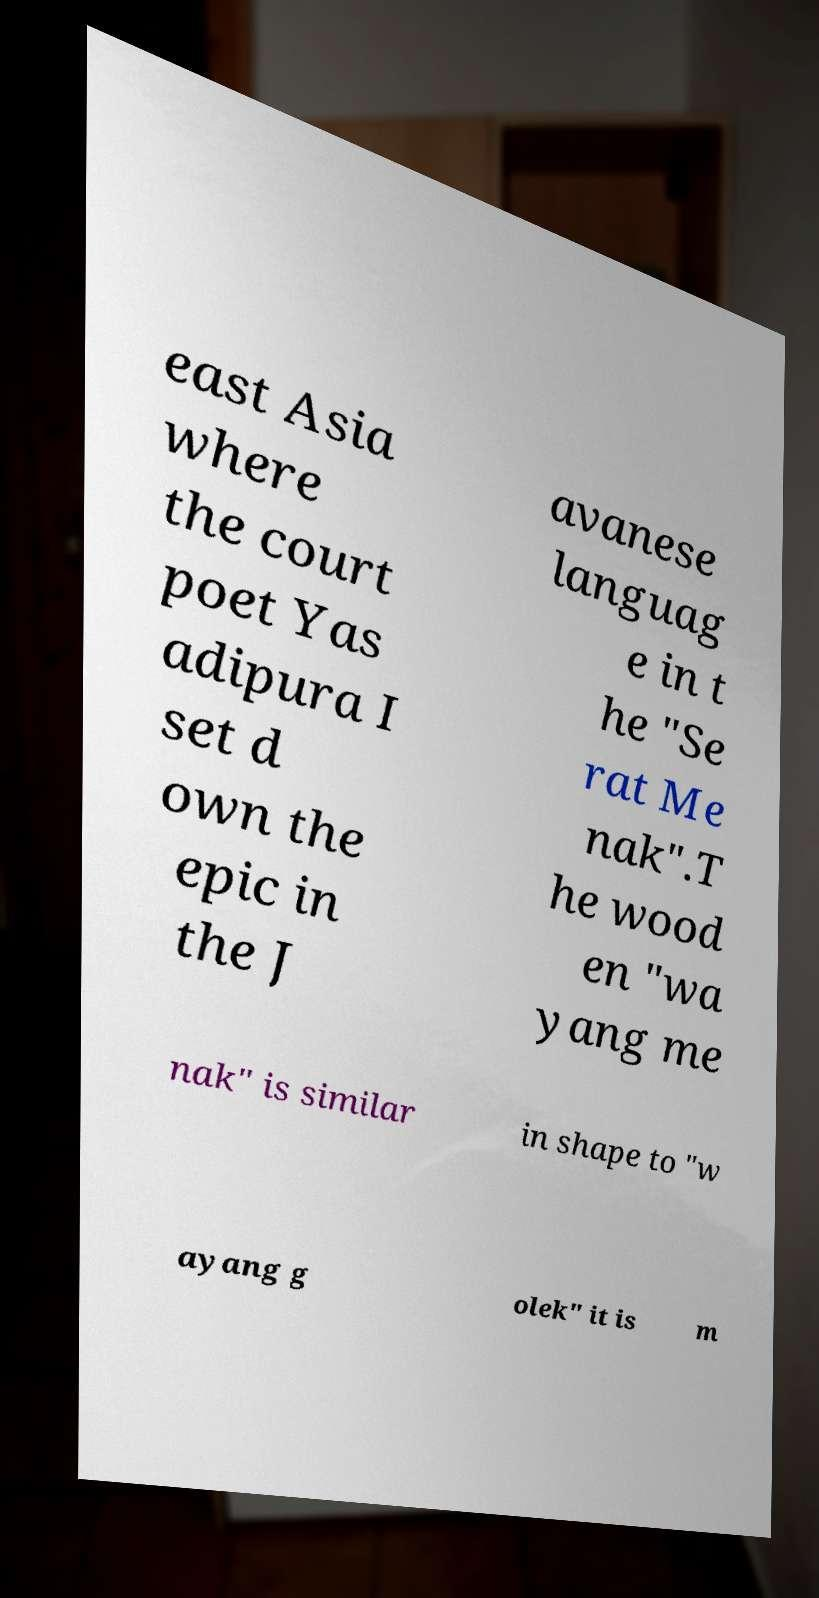Please read and relay the text visible in this image. What does it say? east Asia where the court poet Yas adipura I set d own the epic in the J avanese languag e in t he "Se rat Me nak".T he wood en "wa yang me nak" is similar in shape to "w ayang g olek" it is m 